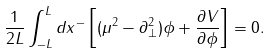Convert formula to latex. <formula><loc_0><loc_0><loc_500><loc_500>\frac { 1 } { 2 L } \int _ { - L } ^ { L } d x ^ { - } \left [ ( \mu ^ { 2 } - \partial _ { \bot } ^ { 2 } ) \phi + \frac { \partial V } { \partial \phi } \right ] = 0 .</formula> 